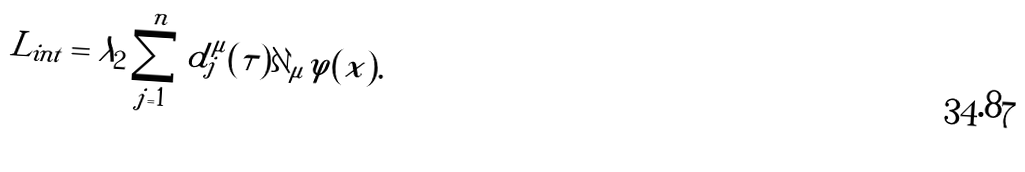<formula> <loc_0><loc_0><loc_500><loc_500>L _ { i n t } = \lambda _ { 2 } \sum _ { j = 1 } ^ { n } d _ { j } ^ { \mu } ( \tau ) \partial _ { \mu } \varphi ( x ) .</formula> 